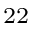<formula> <loc_0><loc_0><loc_500><loc_500>^ { 2 2 }</formula> 